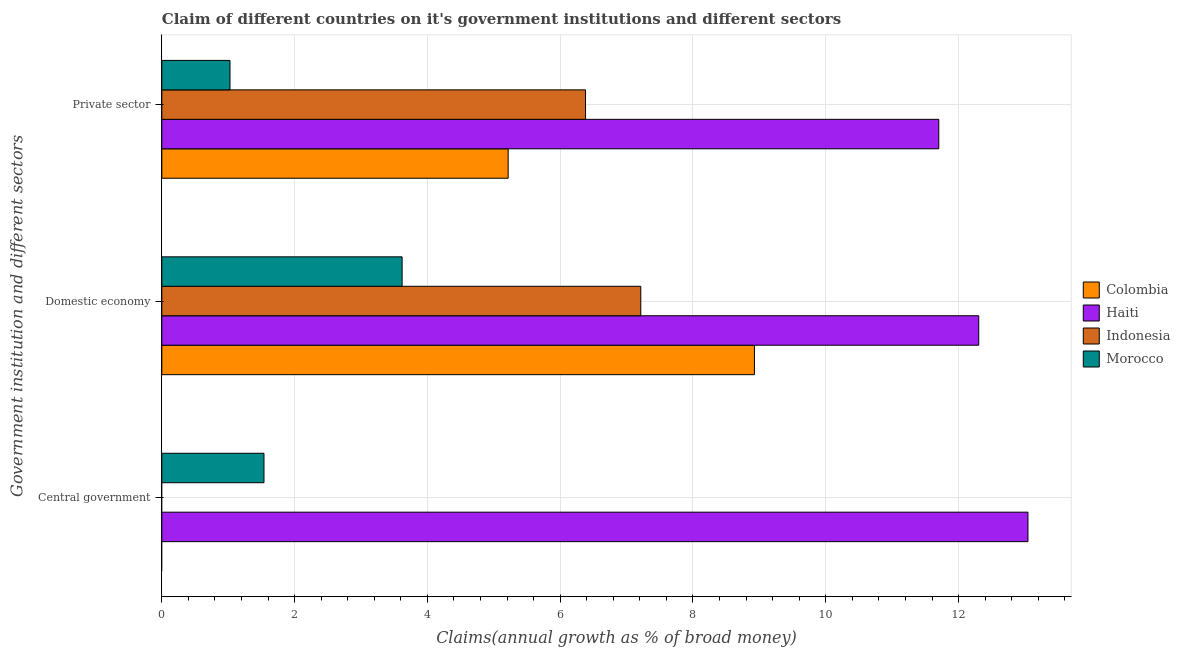How many groups of bars are there?
Offer a terse response. 3. Are the number of bars on each tick of the Y-axis equal?
Provide a short and direct response. No. How many bars are there on the 1st tick from the bottom?
Ensure brevity in your answer.  2. What is the label of the 3rd group of bars from the top?
Make the answer very short. Central government. What is the percentage of claim on the domestic economy in Haiti?
Make the answer very short. 12.3. Across all countries, what is the maximum percentage of claim on the private sector?
Offer a terse response. 11.7. Across all countries, what is the minimum percentage of claim on the private sector?
Offer a very short reply. 1.03. In which country was the percentage of claim on the private sector maximum?
Provide a succinct answer. Haiti. What is the total percentage of claim on the private sector in the graph?
Offer a terse response. 24.33. What is the difference between the percentage of claim on the domestic economy in Morocco and that in Colombia?
Your answer should be very brief. -5.31. What is the difference between the percentage of claim on the domestic economy in Indonesia and the percentage of claim on the central government in Haiti?
Provide a short and direct response. -5.83. What is the average percentage of claim on the domestic economy per country?
Provide a succinct answer. 8.02. What is the difference between the percentage of claim on the private sector and percentage of claim on the domestic economy in Indonesia?
Keep it short and to the point. -0.83. In how many countries, is the percentage of claim on the central government greater than 3.6 %?
Provide a short and direct response. 1. What is the ratio of the percentage of claim on the domestic economy in Colombia to that in Morocco?
Your answer should be very brief. 2.47. What is the difference between the highest and the second highest percentage of claim on the private sector?
Your answer should be compact. 5.32. What is the difference between the highest and the lowest percentage of claim on the domestic economy?
Your answer should be compact. 8.69. Is the sum of the percentage of claim on the private sector in Indonesia and Colombia greater than the maximum percentage of claim on the domestic economy across all countries?
Provide a succinct answer. No. Is it the case that in every country, the sum of the percentage of claim on the central government and percentage of claim on the domestic economy is greater than the percentage of claim on the private sector?
Provide a succinct answer. Yes. How many countries are there in the graph?
Your response must be concise. 4. What is the difference between two consecutive major ticks on the X-axis?
Keep it short and to the point. 2. Are the values on the major ticks of X-axis written in scientific E-notation?
Keep it short and to the point. No. Does the graph contain grids?
Provide a short and direct response. Yes. Where does the legend appear in the graph?
Your answer should be very brief. Center right. What is the title of the graph?
Offer a very short reply. Claim of different countries on it's government institutions and different sectors. Does "Cuba" appear as one of the legend labels in the graph?
Keep it short and to the point. No. What is the label or title of the X-axis?
Your response must be concise. Claims(annual growth as % of broad money). What is the label or title of the Y-axis?
Your answer should be compact. Government institution and different sectors. What is the Claims(annual growth as % of broad money) in Colombia in Central government?
Your answer should be very brief. 0. What is the Claims(annual growth as % of broad money) of Haiti in Central government?
Provide a succinct answer. 13.05. What is the Claims(annual growth as % of broad money) of Morocco in Central government?
Your answer should be very brief. 1.54. What is the Claims(annual growth as % of broad money) in Colombia in Domestic economy?
Offer a very short reply. 8.93. What is the Claims(annual growth as % of broad money) of Haiti in Domestic economy?
Give a very brief answer. 12.3. What is the Claims(annual growth as % of broad money) in Indonesia in Domestic economy?
Make the answer very short. 7.21. What is the Claims(annual growth as % of broad money) in Morocco in Domestic economy?
Your response must be concise. 3.62. What is the Claims(annual growth as % of broad money) of Colombia in Private sector?
Offer a terse response. 5.22. What is the Claims(annual growth as % of broad money) of Haiti in Private sector?
Ensure brevity in your answer.  11.7. What is the Claims(annual growth as % of broad money) of Indonesia in Private sector?
Offer a terse response. 6.38. What is the Claims(annual growth as % of broad money) of Morocco in Private sector?
Provide a succinct answer. 1.03. Across all Government institution and different sectors, what is the maximum Claims(annual growth as % of broad money) of Colombia?
Offer a very short reply. 8.93. Across all Government institution and different sectors, what is the maximum Claims(annual growth as % of broad money) of Haiti?
Keep it short and to the point. 13.05. Across all Government institution and different sectors, what is the maximum Claims(annual growth as % of broad money) in Indonesia?
Provide a short and direct response. 7.21. Across all Government institution and different sectors, what is the maximum Claims(annual growth as % of broad money) in Morocco?
Offer a very short reply. 3.62. Across all Government institution and different sectors, what is the minimum Claims(annual growth as % of broad money) in Haiti?
Provide a short and direct response. 11.7. Across all Government institution and different sectors, what is the minimum Claims(annual growth as % of broad money) in Morocco?
Offer a terse response. 1.03. What is the total Claims(annual growth as % of broad money) of Colombia in the graph?
Offer a terse response. 14.14. What is the total Claims(annual growth as % of broad money) of Haiti in the graph?
Provide a succinct answer. 37.05. What is the total Claims(annual growth as % of broad money) in Indonesia in the graph?
Your answer should be compact. 13.6. What is the total Claims(annual growth as % of broad money) of Morocco in the graph?
Your answer should be compact. 6.18. What is the difference between the Claims(annual growth as % of broad money) of Haiti in Central government and that in Domestic economy?
Offer a very short reply. 0.74. What is the difference between the Claims(annual growth as % of broad money) of Morocco in Central government and that in Domestic economy?
Your answer should be very brief. -2.08. What is the difference between the Claims(annual growth as % of broad money) in Haiti in Central government and that in Private sector?
Offer a terse response. 1.34. What is the difference between the Claims(annual growth as % of broad money) in Morocco in Central government and that in Private sector?
Make the answer very short. 0.51. What is the difference between the Claims(annual growth as % of broad money) in Colombia in Domestic economy and that in Private sector?
Keep it short and to the point. 3.71. What is the difference between the Claims(annual growth as % of broad money) of Haiti in Domestic economy and that in Private sector?
Your answer should be very brief. 0.6. What is the difference between the Claims(annual growth as % of broad money) of Indonesia in Domestic economy and that in Private sector?
Keep it short and to the point. 0.83. What is the difference between the Claims(annual growth as % of broad money) in Morocco in Domestic economy and that in Private sector?
Your answer should be compact. 2.59. What is the difference between the Claims(annual growth as % of broad money) in Haiti in Central government and the Claims(annual growth as % of broad money) in Indonesia in Domestic economy?
Your answer should be compact. 5.83. What is the difference between the Claims(annual growth as % of broad money) in Haiti in Central government and the Claims(annual growth as % of broad money) in Morocco in Domestic economy?
Make the answer very short. 9.43. What is the difference between the Claims(annual growth as % of broad money) of Haiti in Central government and the Claims(annual growth as % of broad money) of Indonesia in Private sector?
Provide a short and direct response. 6.66. What is the difference between the Claims(annual growth as % of broad money) of Haiti in Central government and the Claims(annual growth as % of broad money) of Morocco in Private sector?
Provide a succinct answer. 12.02. What is the difference between the Claims(annual growth as % of broad money) of Colombia in Domestic economy and the Claims(annual growth as % of broad money) of Haiti in Private sector?
Make the answer very short. -2.78. What is the difference between the Claims(annual growth as % of broad money) in Colombia in Domestic economy and the Claims(annual growth as % of broad money) in Indonesia in Private sector?
Your answer should be very brief. 2.54. What is the difference between the Claims(annual growth as % of broad money) of Colombia in Domestic economy and the Claims(annual growth as % of broad money) of Morocco in Private sector?
Provide a succinct answer. 7.9. What is the difference between the Claims(annual growth as % of broad money) in Haiti in Domestic economy and the Claims(annual growth as % of broad money) in Indonesia in Private sector?
Provide a succinct answer. 5.92. What is the difference between the Claims(annual growth as % of broad money) of Haiti in Domestic economy and the Claims(annual growth as % of broad money) of Morocco in Private sector?
Your response must be concise. 11.28. What is the difference between the Claims(annual growth as % of broad money) of Indonesia in Domestic economy and the Claims(annual growth as % of broad money) of Morocco in Private sector?
Offer a very short reply. 6.19. What is the average Claims(annual growth as % of broad money) of Colombia per Government institution and different sectors?
Offer a very short reply. 4.71. What is the average Claims(annual growth as % of broad money) of Haiti per Government institution and different sectors?
Offer a very short reply. 12.35. What is the average Claims(annual growth as % of broad money) in Indonesia per Government institution and different sectors?
Offer a very short reply. 4.53. What is the average Claims(annual growth as % of broad money) in Morocco per Government institution and different sectors?
Ensure brevity in your answer.  2.06. What is the difference between the Claims(annual growth as % of broad money) of Haiti and Claims(annual growth as % of broad money) of Morocco in Central government?
Keep it short and to the point. 11.51. What is the difference between the Claims(annual growth as % of broad money) in Colombia and Claims(annual growth as % of broad money) in Haiti in Domestic economy?
Your response must be concise. -3.38. What is the difference between the Claims(annual growth as % of broad money) in Colombia and Claims(annual growth as % of broad money) in Indonesia in Domestic economy?
Offer a very short reply. 1.71. What is the difference between the Claims(annual growth as % of broad money) in Colombia and Claims(annual growth as % of broad money) in Morocco in Domestic economy?
Make the answer very short. 5.31. What is the difference between the Claims(annual growth as % of broad money) of Haiti and Claims(annual growth as % of broad money) of Indonesia in Domestic economy?
Ensure brevity in your answer.  5.09. What is the difference between the Claims(annual growth as % of broad money) of Haiti and Claims(annual growth as % of broad money) of Morocco in Domestic economy?
Give a very brief answer. 8.69. What is the difference between the Claims(annual growth as % of broad money) in Indonesia and Claims(annual growth as % of broad money) in Morocco in Domestic economy?
Your response must be concise. 3.59. What is the difference between the Claims(annual growth as % of broad money) of Colombia and Claims(annual growth as % of broad money) of Haiti in Private sector?
Offer a very short reply. -6.49. What is the difference between the Claims(annual growth as % of broad money) of Colombia and Claims(annual growth as % of broad money) of Indonesia in Private sector?
Your response must be concise. -1.17. What is the difference between the Claims(annual growth as % of broad money) in Colombia and Claims(annual growth as % of broad money) in Morocco in Private sector?
Offer a terse response. 4.19. What is the difference between the Claims(annual growth as % of broad money) of Haiti and Claims(annual growth as % of broad money) of Indonesia in Private sector?
Provide a short and direct response. 5.32. What is the difference between the Claims(annual growth as % of broad money) of Haiti and Claims(annual growth as % of broad money) of Morocco in Private sector?
Your response must be concise. 10.68. What is the difference between the Claims(annual growth as % of broad money) in Indonesia and Claims(annual growth as % of broad money) in Morocco in Private sector?
Your answer should be very brief. 5.35. What is the ratio of the Claims(annual growth as % of broad money) of Haiti in Central government to that in Domestic economy?
Ensure brevity in your answer.  1.06. What is the ratio of the Claims(annual growth as % of broad money) in Morocco in Central government to that in Domestic economy?
Keep it short and to the point. 0.43. What is the ratio of the Claims(annual growth as % of broad money) of Haiti in Central government to that in Private sector?
Your answer should be compact. 1.11. What is the ratio of the Claims(annual growth as % of broad money) in Morocco in Central government to that in Private sector?
Provide a succinct answer. 1.5. What is the ratio of the Claims(annual growth as % of broad money) in Colombia in Domestic economy to that in Private sector?
Provide a short and direct response. 1.71. What is the ratio of the Claims(annual growth as % of broad money) in Haiti in Domestic economy to that in Private sector?
Provide a short and direct response. 1.05. What is the ratio of the Claims(annual growth as % of broad money) of Indonesia in Domestic economy to that in Private sector?
Offer a terse response. 1.13. What is the ratio of the Claims(annual growth as % of broad money) of Morocco in Domestic economy to that in Private sector?
Your answer should be compact. 3.53. What is the difference between the highest and the second highest Claims(annual growth as % of broad money) in Haiti?
Your response must be concise. 0.74. What is the difference between the highest and the second highest Claims(annual growth as % of broad money) in Morocco?
Make the answer very short. 2.08. What is the difference between the highest and the lowest Claims(annual growth as % of broad money) of Colombia?
Make the answer very short. 8.93. What is the difference between the highest and the lowest Claims(annual growth as % of broad money) in Haiti?
Your answer should be very brief. 1.34. What is the difference between the highest and the lowest Claims(annual growth as % of broad money) of Indonesia?
Provide a succinct answer. 7.21. What is the difference between the highest and the lowest Claims(annual growth as % of broad money) of Morocco?
Give a very brief answer. 2.59. 